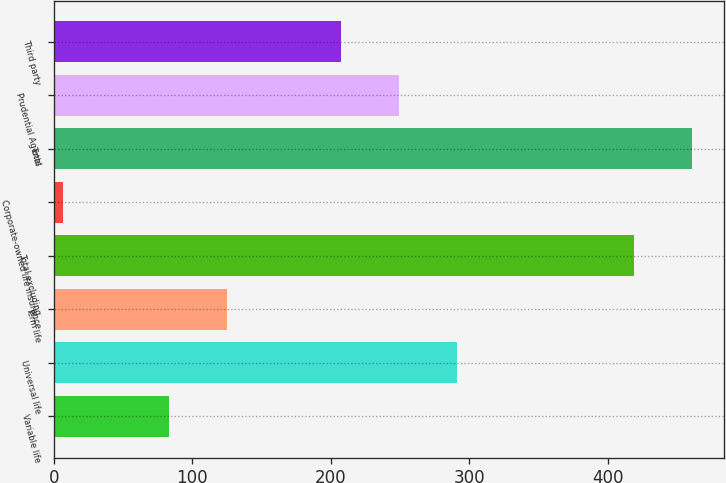Convert chart. <chart><loc_0><loc_0><loc_500><loc_500><bar_chart><fcel>Variable life<fcel>Universal life<fcel>Term life<fcel>Total excluding<fcel>Corporate-owned life insurance<fcel>Total<fcel>Prudential Agents<fcel>Third party<nl><fcel>83<fcel>290.8<fcel>124.9<fcel>419<fcel>7<fcel>460.9<fcel>248.9<fcel>207<nl></chart> 